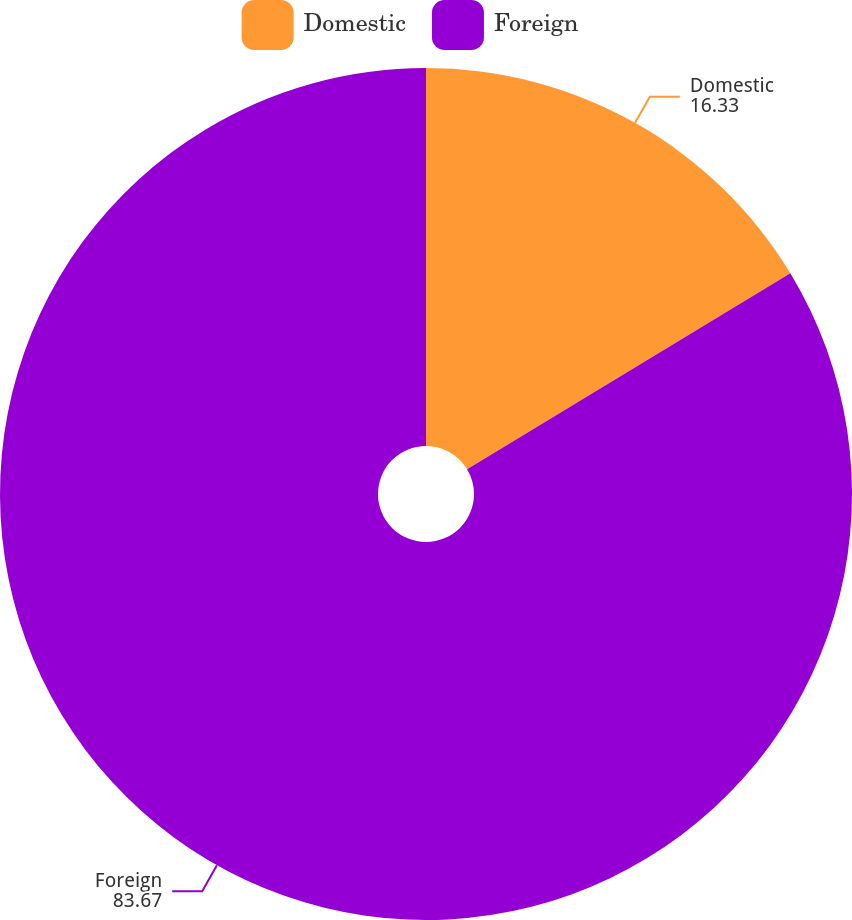Convert chart to OTSL. <chart><loc_0><loc_0><loc_500><loc_500><pie_chart><fcel>Domestic<fcel>Foreign<nl><fcel>16.33%<fcel>83.67%<nl></chart> 